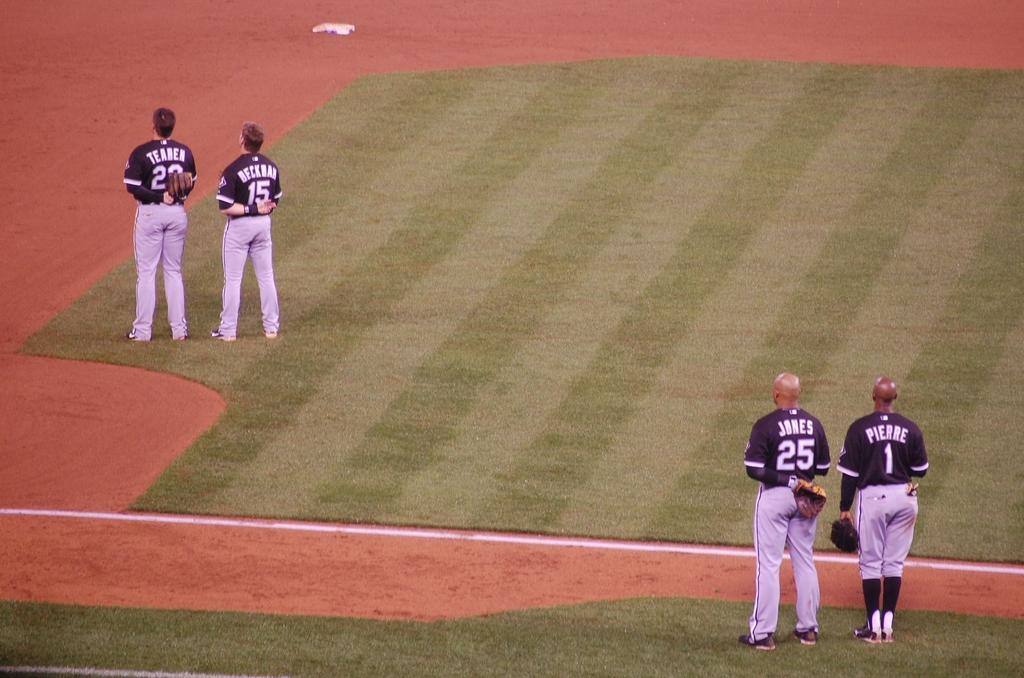James number is?
Offer a terse response. 25. 